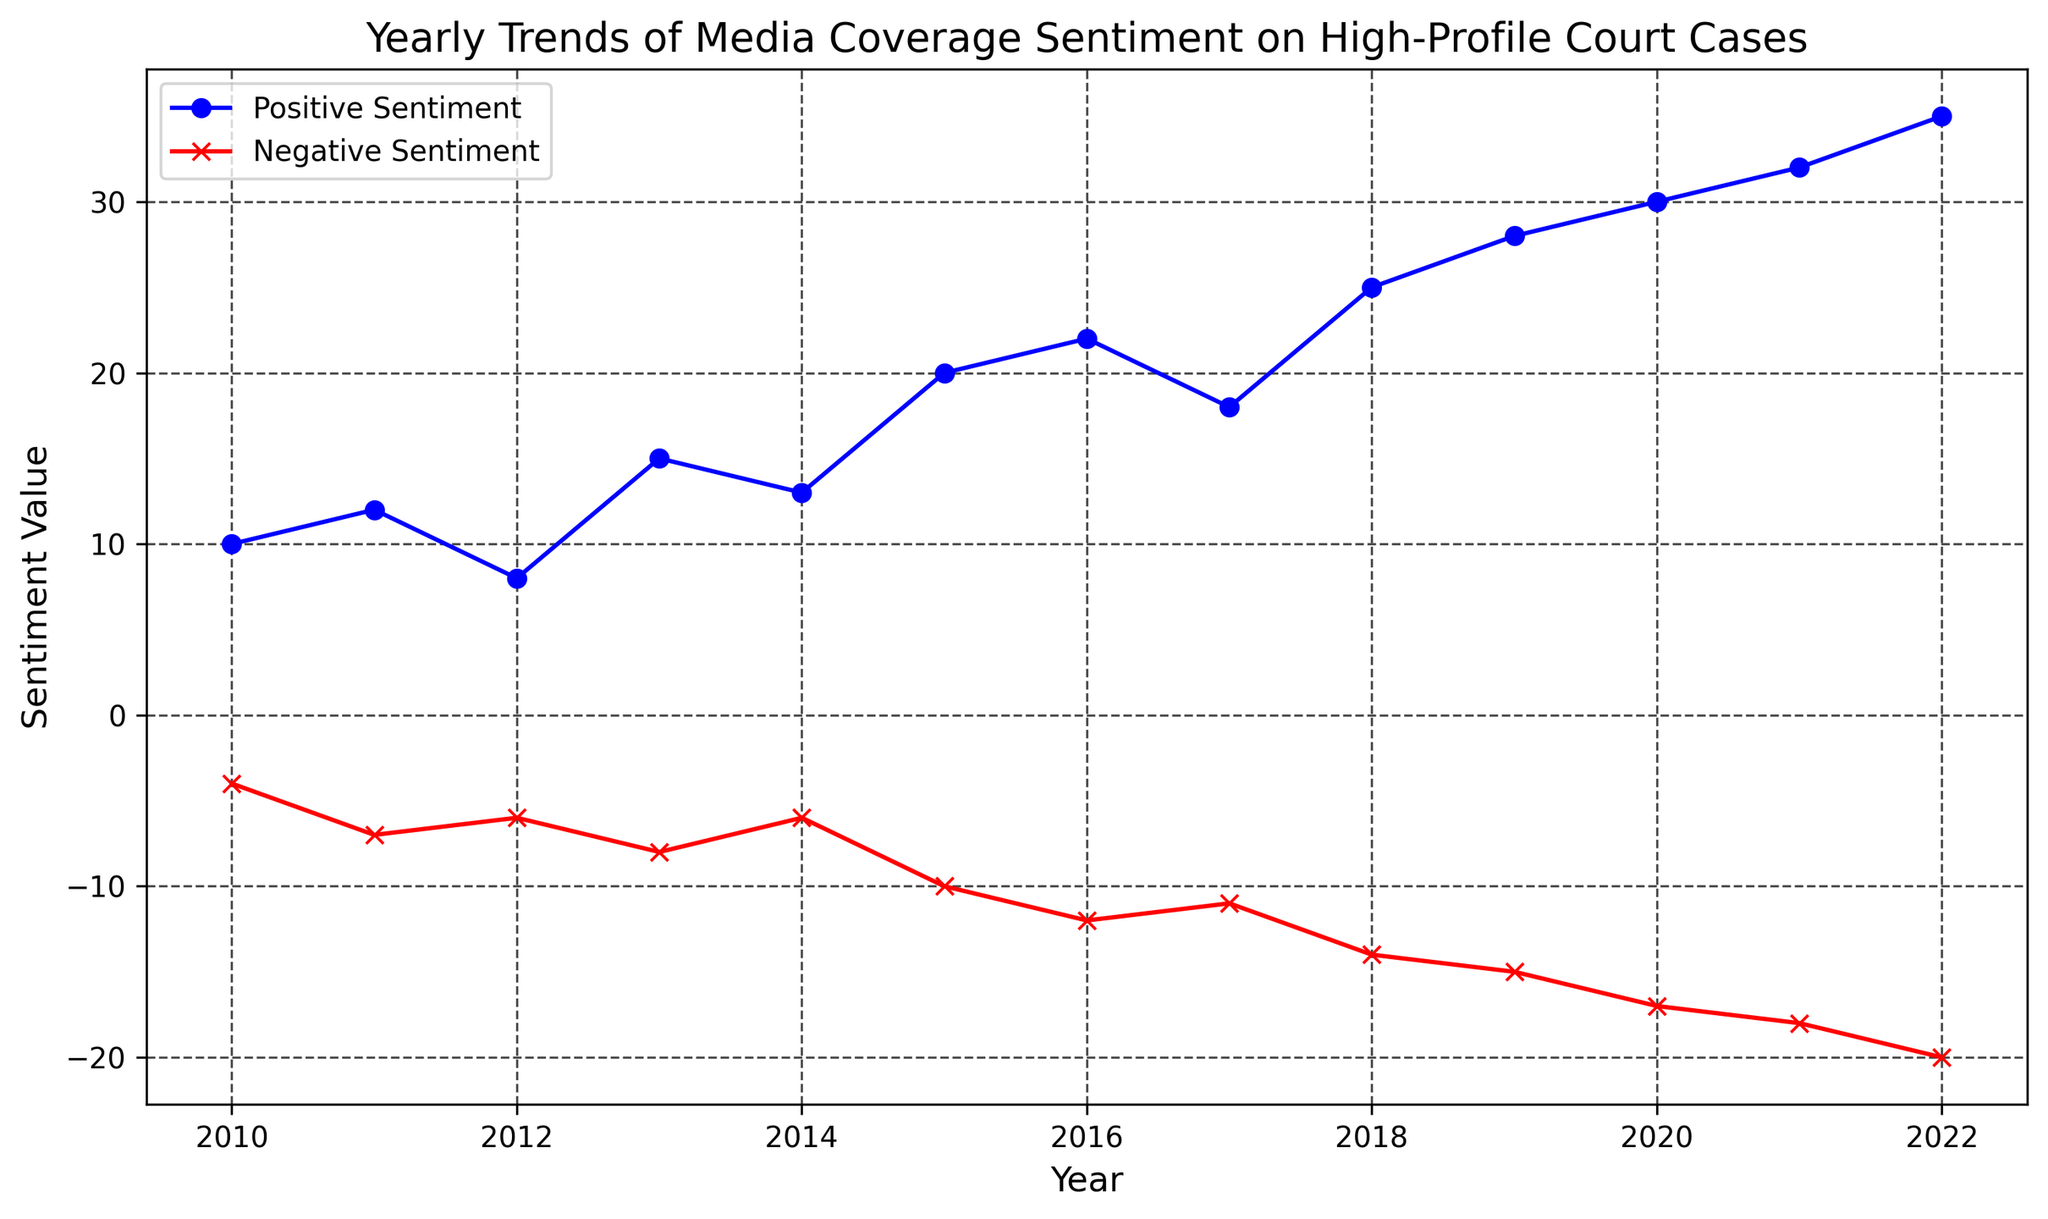What is the range of Positive Sentiment values from 2010 to 2022? To find the range, we need to take the maximum Positive Sentiment value and subtract the minimum Positive Sentiment value. The max value is 35 (in 2022) and the min value is 8 (in 2012). Thus, the range is 35 - 8 = 27
Answer: 27 Which year had the highest Negative Sentiment value? To determine the year with the highest Negative Sentiment, we look for the most negative (lowest) value, which is -20 in 2022.
Answer: 2022 Compare the Positive and Negative Sentiment values in 2015. Which one is higher? In 2015, the Positive Sentiment value is 20 and the Negative Sentiment value is -10. Since 20 is greater than -10, the Positive Sentiment is higher.
Answer: Positive Sentiment In which year did Positive Sentiment values start to consistently increase year-over-year? To find this, we observe the Positive Sentiment values each year and note when they begin consistently increasing. Starting from 2010, the values fluctuate until 2015. From 2015 onwards, Positive Sentiment values increase each year.
Answer: 2015 What is the difference in Negative Sentiment values between 2017 and 2018? To find this, subtract the Negative Sentiment value of 2017 from that of 2018. The value in 2017 is -11 and in 2018 is -14, so the difference is -14 - (-11) = -3.
Answer: -3 What is the average Positive Sentiment value over the entire period from 2010 to 2022? To calculate the average, sum all the Positive Sentiment values and divide by the number of years. Sum = 10 + 12 + 8 + 15 + 13 + 20 + 22 + 18 + 25 + 28 + 30 + 32 + 35 = 268. Number of years = 13. Average = 268 / 13 ≈ 20.62
Answer: 20.62 In which year did the Negative Sentiment see the largest single-year increase? We need to calculate the year-to-year differences in Negative Sentiment and find the largest increase. The largest increase occurs between 2015 and 2016, where the change is -12 - (-10) = -2.
Answer: 2016 Which sentiment (positive or negative) had a more significant increase from 2010 to 2022? The Positive Sentiment increased from 10 to 35 (an increase of 25), while the Negative Sentiment decreased from -4 to -20 (a decrease of 16). Since 25 is greater than 16, the Positive Sentiment had a more significant increase.
Answer: Positive Sentiment What was the Positive Sentiment value in the median year of the dataset? The median year of the dataset from 2010 to 2022 (13 years) is the 7th year, which is 2016. In 2016, the Positive Sentiment value is 22.
Answer: 22 What is the sum of Negative Sentiment values for the years 2010 and 2022? Add the Negative Sentiment values for 2010 and 2022. The value for 2010 is -4 and for 2022 is -20. Sum = -4 + (-20) = -24.
Answer: -24 